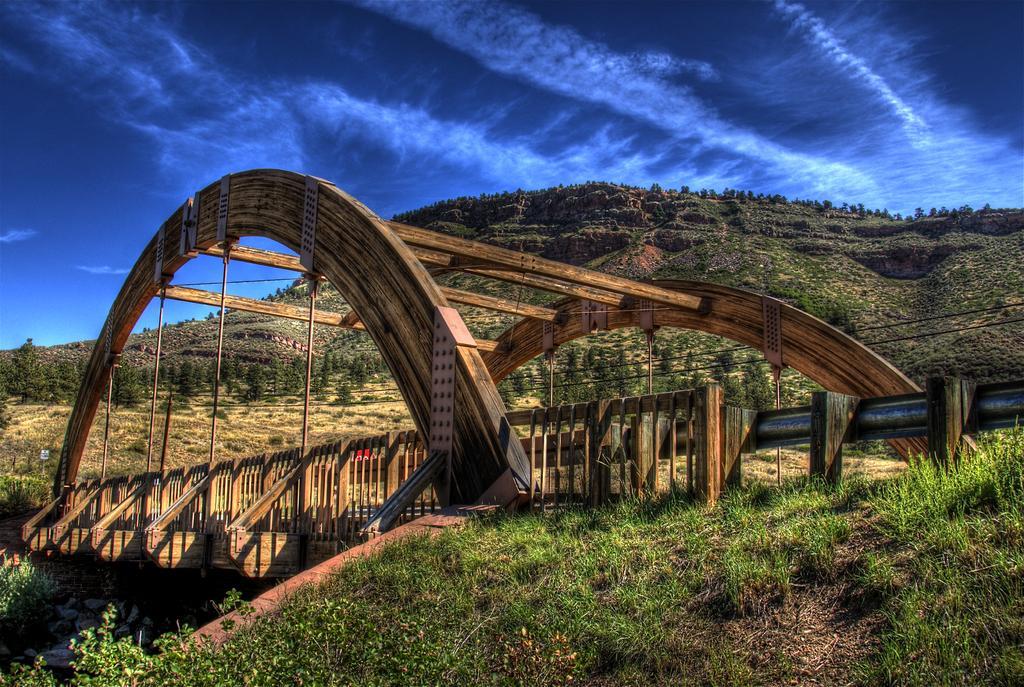Could you give a brief overview of what you see in this image? In this image, we can see a bridge and we can see hills, stones and there is an arch. At the top, there is sky and at the bottom, there is ground covered with grass and plants. 